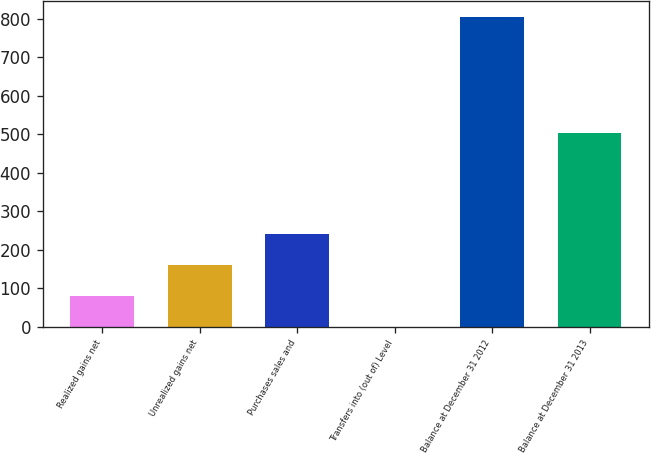Convert chart. <chart><loc_0><loc_0><loc_500><loc_500><bar_chart><fcel>Realized gains net<fcel>Unrealized gains net<fcel>Purchases sales and<fcel>Transfers into (out of) Level<fcel>Balance at December 31 2012<fcel>Balance at December 31 2013<nl><fcel>81.5<fcel>162<fcel>242.5<fcel>1<fcel>806<fcel>505<nl></chart> 